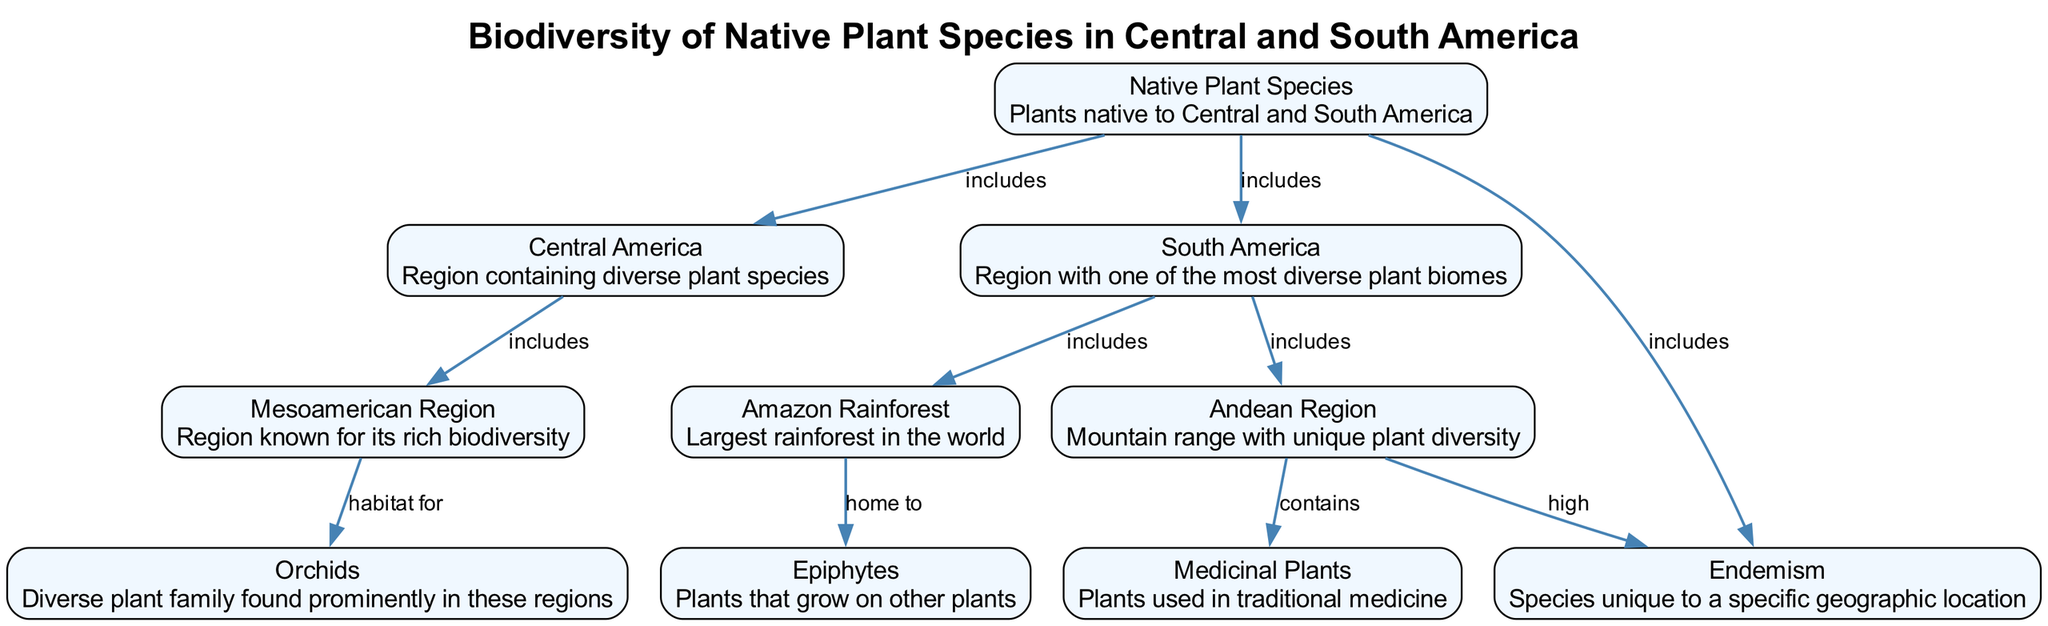What is the title of the diagram? The title of the diagram is explicitly stated in the data provided, which is "Biodiversity of Native Plant Species in Central and South America."
Answer: Biodiversity of Native Plant Species in Central and South America How many nodes are present in the diagram? The data specifies a total of ten nodes representing various aspects of native plant species in the regions, indicating there are 10 nodes.
Answer: 10 Which region includes the Amazon Rainforest? The Amazon Rainforest is connected to the South America node through an edge labeled "includes," indicating that the rainforest is a part of this region.
Answer: South America What type of plants are epiphytes? The description for the node labeled "Epiphytes" states that these are "plants that grow on other plants," providing a clear definition of the type of plants.
Answer: plants that grow on other plants Which region is known for its rich biodiversity? The Mesoamerican Region node specifically mentions being "known for its rich biodiversity," directly indicating its significance regarding native plant species.
Answer: Mesoamerican Region How are medicinal plants associated with the Andean Region? The edge between the Andean Region and Medicinal Plants states that this region "contains" medicinal plants, establishing a direct connection regarding their presence.
Answer: contains What relationship does endemism have with native plant species? The native plant species node indicates that it "includes" endemism, meaning that native plants consist of species that are unique to specific locations.
Answer: includes Which plant family is highlighted as diverse in the Mesoamerican Region? The Mesoamerican Region is described as a "habitat for" orchids, indicating the specific family that thrives in this area.
Answer: orchids What is significant about the Andean Region concerning endemism? The Andean Region is associated with "high" endemism, indicating a greater number of unique species present in this mountainous area compared to others.
Answer: high 